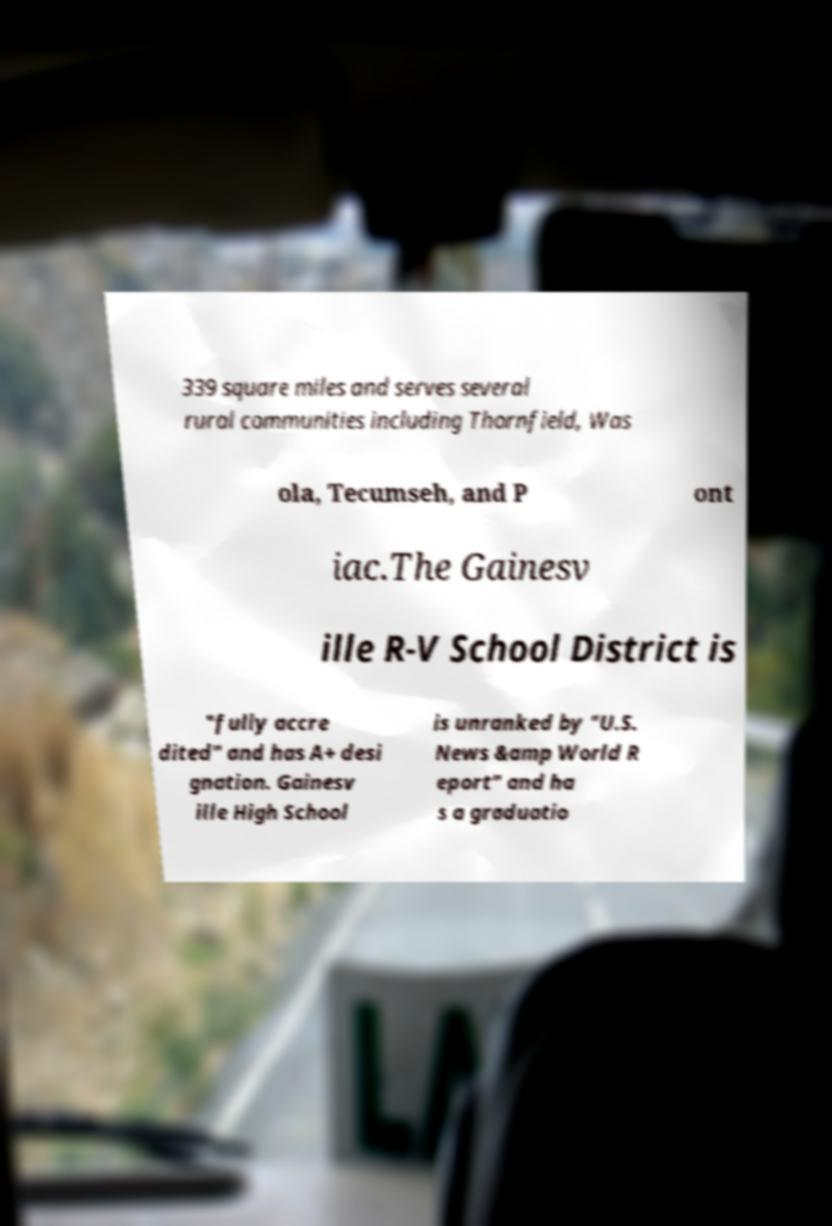Could you assist in decoding the text presented in this image and type it out clearly? 339 square miles and serves several rural communities including Thornfield, Was ola, Tecumseh, and P ont iac.The Gainesv ille R-V School District is "fully accre dited" and has A+ desi gnation. Gainesv ille High School is unranked by "U.S. News &amp World R eport" and ha s a graduatio 